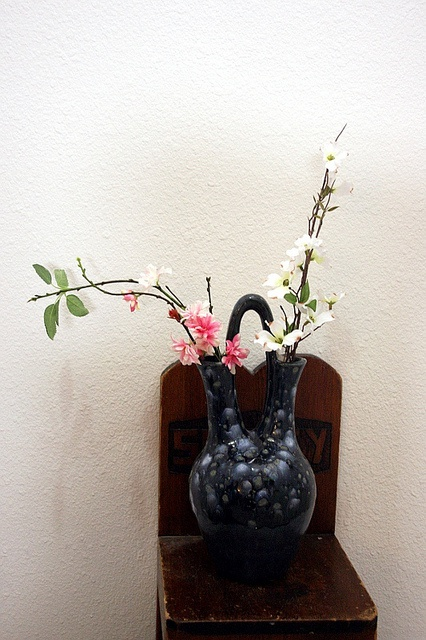Describe the objects in this image and their specific colors. I can see potted plant in lightgray, black, ivory, gray, and beige tones, chair in lightgray, black, maroon, and gray tones, and vase in lightgray, black, gray, and darkgray tones in this image. 